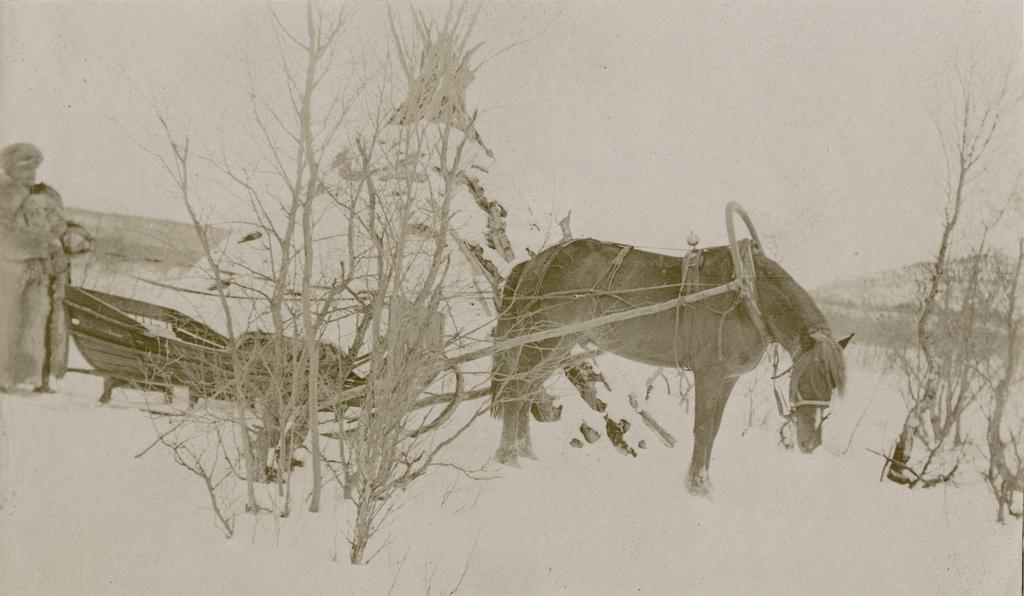What is the main subject in the center of the image? There is a horse in the center of the image. What can be seen on the left side of the image? There is a person on the left side of the image. What is the person associated with? There is a cart associated with the person. What can be seen in the background of the image? There are trees and the sky visible in the background of the image. What book is the person reading while riding the horse in the image? There is no book present in the image, and the person is not reading while riding the horse. 